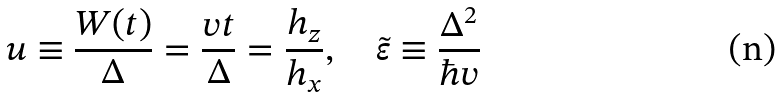<formula> <loc_0><loc_0><loc_500><loc_500>u \equiv \frac { W ( t ) } { \Delta } = \frac { v t } { \Delta } = \frac { h _ { z } } { h _ { x } } , \quad \tilde { \varepsilon } \equiv \frac { \Delta ^ { 2 } } { \hbar { v } }</formula> 